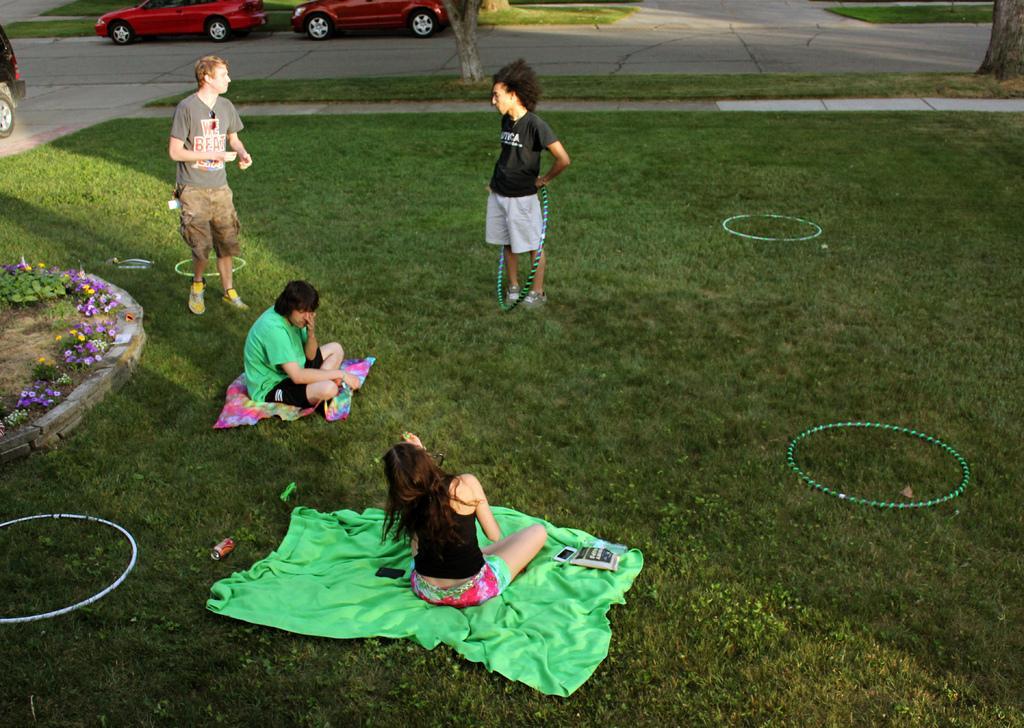In one or two sentences, can you explain what this image depicts? In this image there is a ground on which there are four kids. There is a girl in the middle who is sitting on the green cloth. Beside her there is another kid who is sitting on the mat. In the middle there is a person who is standing on the ground by holding the ring. On the left side there are flower plants. There are rings on the ground. In the background there are two cars on the road. 